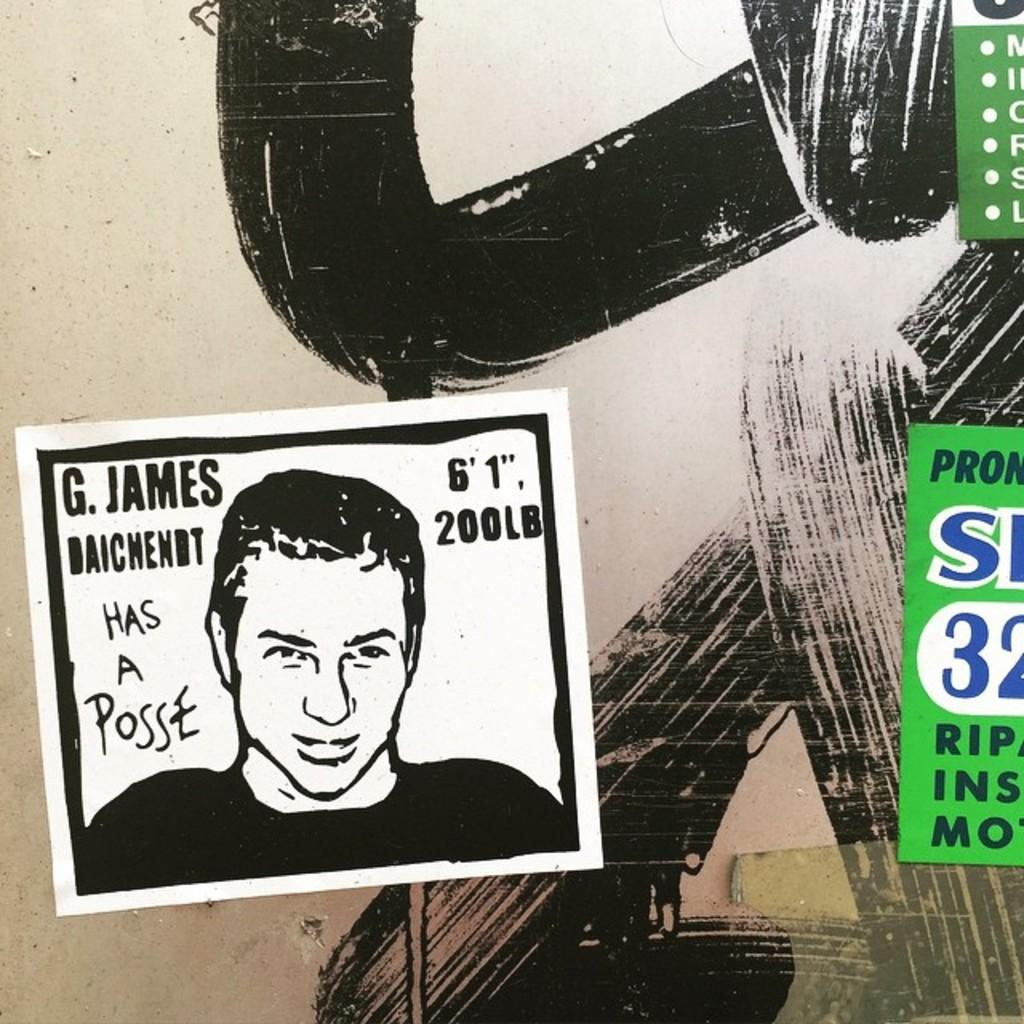What type of visuals are present on the walls in the image? There are posters in the image. What can be seen in the background of the image? There is a painting in the background of the image. What is written on the posters? There is writing on the posters. What type of machine is depicted in the painting in the image? There is no machine depicted in the painting in the image; it is not mentioned in the provided facts. 